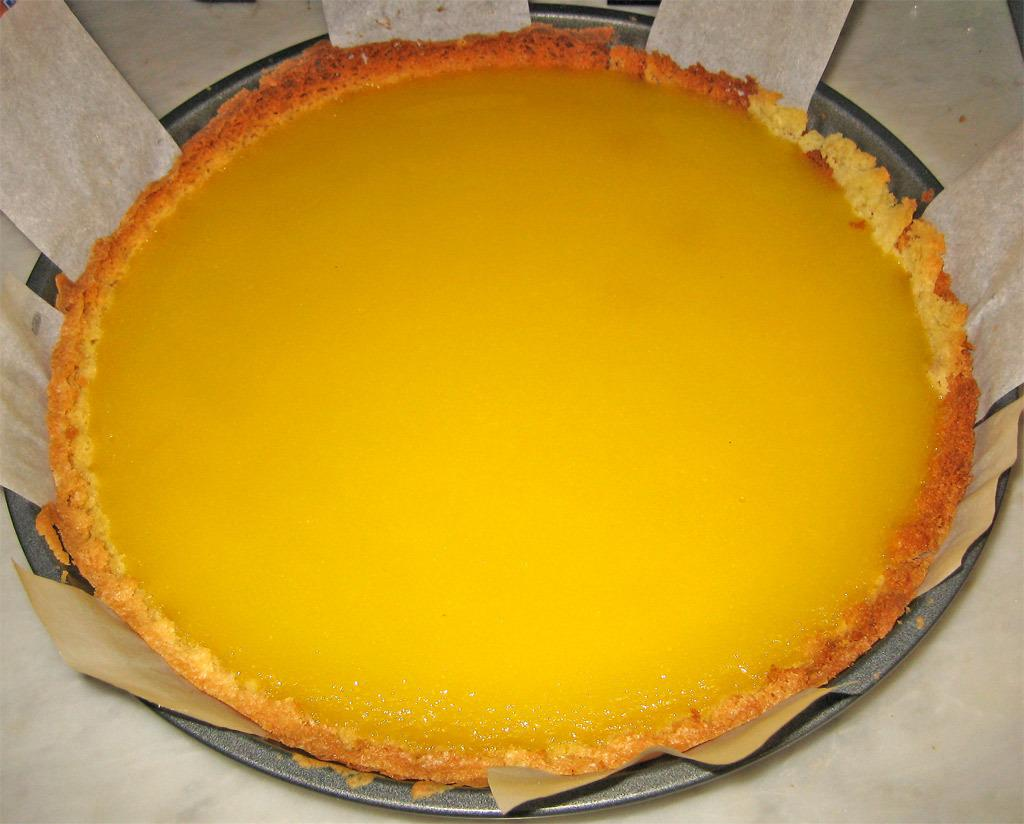What is located on the table in the image? There is a bowl on the table in the image. What is inside the bowl? There are food items inside the bowl. How many horses are visible on the stage in the image? There are no horses or stage present in the image. Is there a tiger lurking behind the food items in the bowl? No, there is no tiger present in the image. 